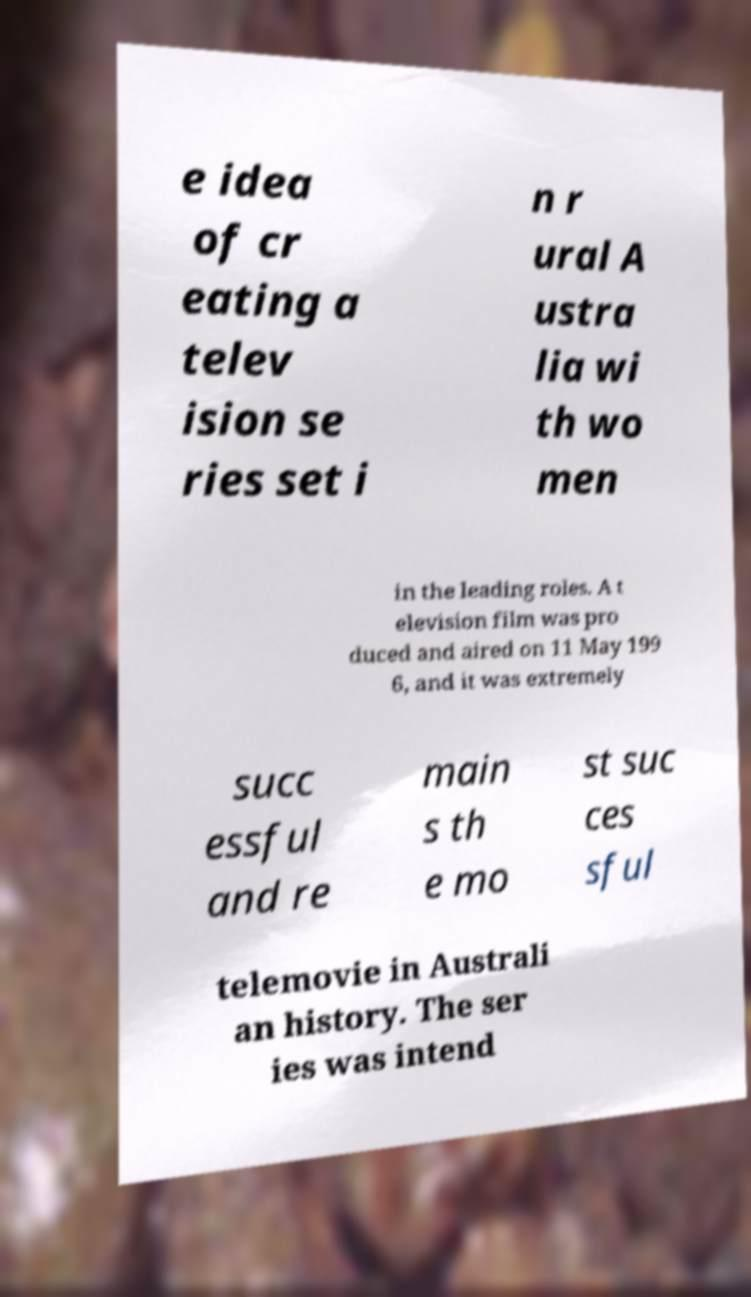Please read and relay the text visible in this image. What does it say? e idea of cr eating a telev ision se ries set i n r ural A ustra lia wi th wo men in the leading roles. A t elevision film was pro duced and aired on 11 May 199 6, and it was extremely succ essful and re main s th e mo st suc ces sful telemovie in Australi an history. The ser ies was intend 